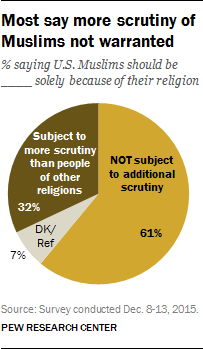Identify some key points in this picture. Out of the individuals subjected to additional scrutiny, 61% chose not to participate. The color of the second largest pie is brown. 